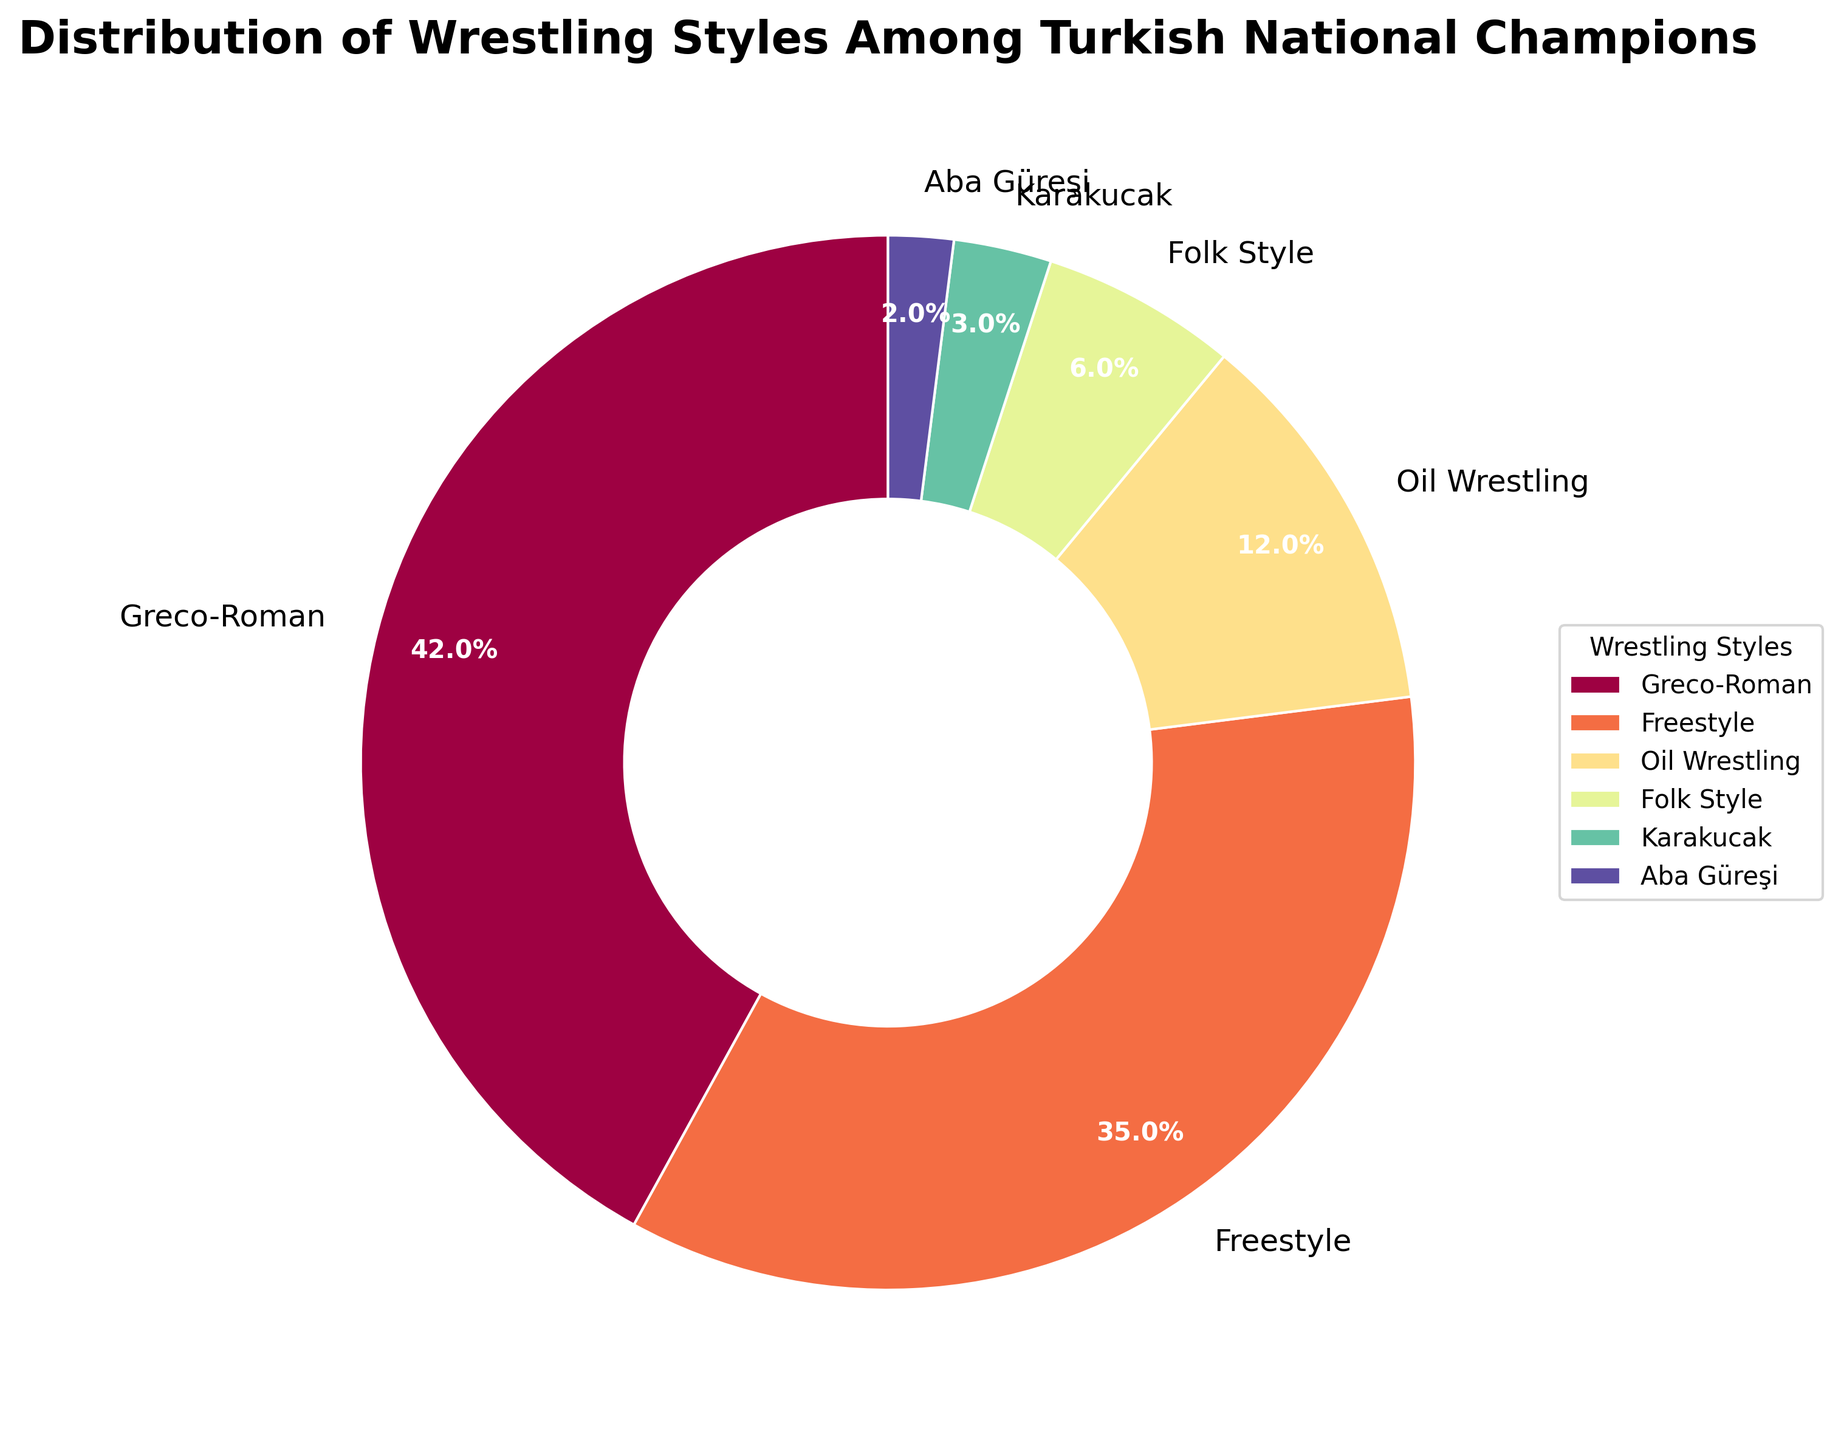What wrestling style has the largest percentage among Turkish national champions? Greco-Roman wrestling has the largest percentage in the pie chart, represented by the biggest wedge. Its label also shows 42%, which is the highest value.
Answer: Greco-Roman What is the combined percentage of Oil Wrestling and Folk Style? To find the combined percentage, add the percentages of Oil Wrestling and Folk Style from the pie chart. Oil Wrestling is 12%, and Folk Style is 6%. Adding these together, 12% + 6% = 18%.
Answer: 18% Which wrestling styles have a smaller percentage than Freestyle? By comparing the percentages, Greco-Roman (42%) and Freestyle (35%) are greater, while Oil Wrestling (12%), Folk Style (6%), Karakucak (3%), and Aba Güreşi (2%) are smaller. Thus, Oil Wrestling, Folk Style, Karakucak, and Aba Güreşi have smaller percentages than Freestyle.
Answer: Oil Wrestling, Folk Style, Karakucak, Aba Güreşi What are the two smallest wrestling styles in terms of percentage? By examining the percentages on the pie chart, Karakucak has 3% and Aba Güreşi has 2%, making them the two smallest wrestling styles in terms of percentage.
Answer: Karakucak, Aba Güreşi Which wrestling styles are represented by wedges closest in size to each other? Comparing the wedge sizes visually and their accompanying percentages, Oil Wrestling (12%) and Folk Style (6%) have a significant difference. However, Karakucak (3%) and Aba Güreşi (2%) are closest in size given their small percentage difference of 1%.
Answer: Karakucak, Aba Güreşi How much larger is the percentage of Greco-Roman wrestling compared to Karakucak? Subtract the percentage of Karakucak from Greco-Roman. Greco-Roman is 42% and Karakucak is 3%. So, 42% - 3% = 39%. Greco-Roman is 39% larger.
Answer: 39% If you exclude the top two wrestling styles, what is the total percentage of the remaining styles? Exclude Greco-Roman and Freestyle which make up 42% and 35% respectively. So the other styles are Oil Wrestling (12%), Folk Style (6%), Karakucak (3%), and Aba Güreşi (2%). Sum their percentages: 12% + 6% + 3% + 2% = 23%.
Answer: 23% Which sector of the pie chart is depicted in darkest color, and which style does it represent? The visual attribute of the pie chart shows that the darkest color represents Greco-Roman wrestling (42%).
Answer: Greco-Roman 